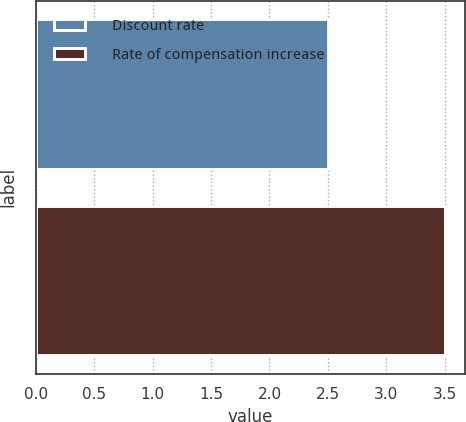Convert chart to OTSL. <chart><loc_0><loc_0><loc_500><loc_500><bar_chart><fcel>Discount rate<fcel>Rate of compensation increase<nl><fcel>2.5<fcel>3.5<nl></chart> 